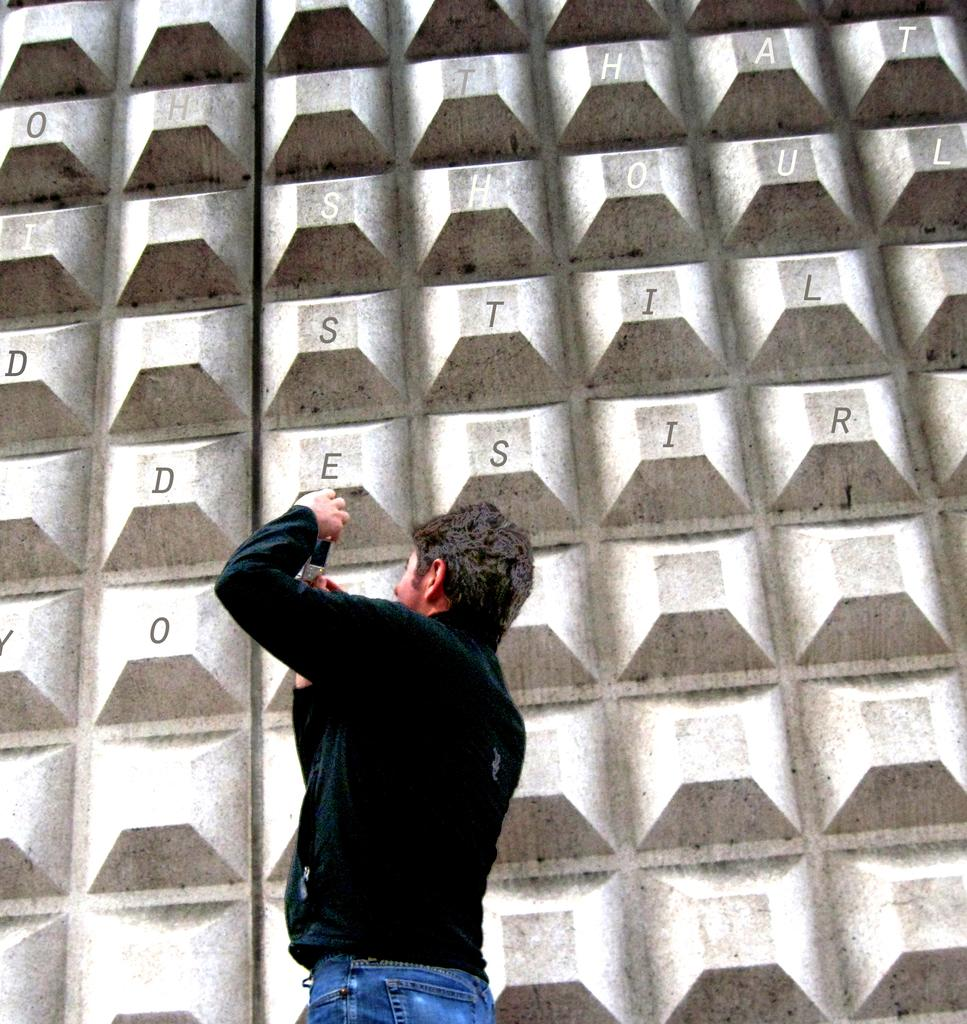Who or what is the main subject in the image? There is a person in the image. What is the person wearing? The person is wearing a black jacket. What can be seen in the background of the image? There is a wall in the background of the image. What is written or depicted on the wall? There is text on the wall. Is there a stove visible in the image? No, there is no stove present in the image. What type of farm animals can be seen in the image? There are no farm animals depicted in the image. 